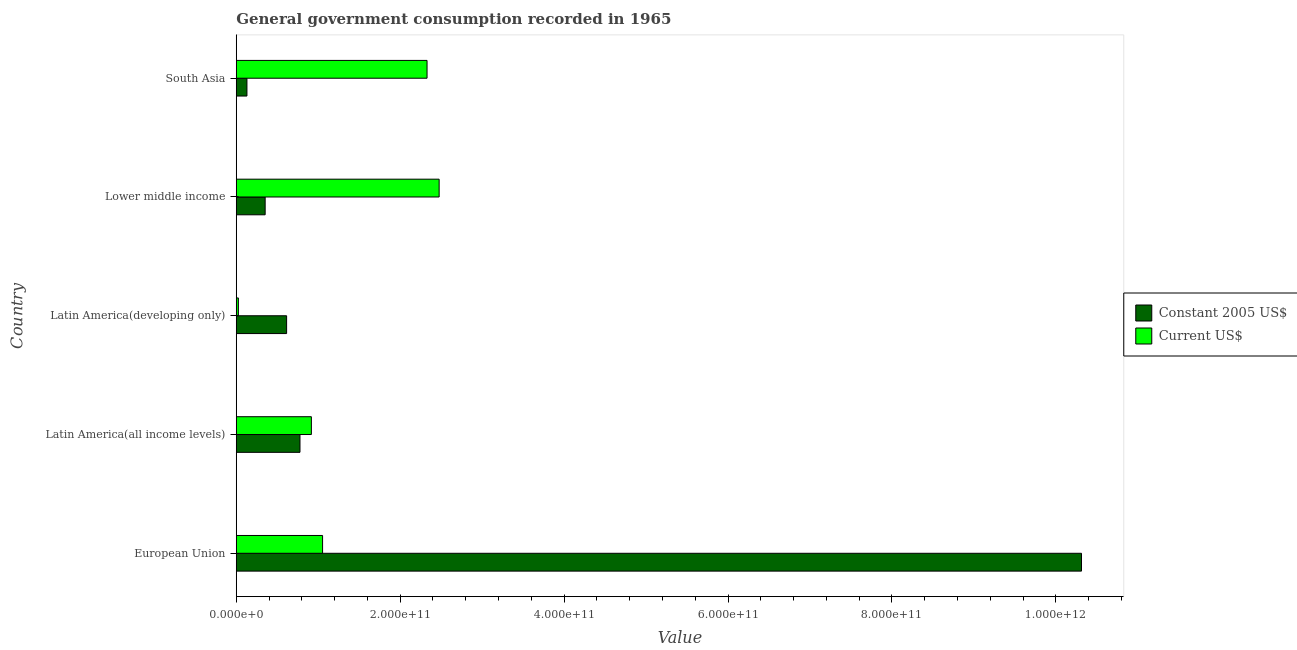How many groups of bars are there?
Ensure brevity in your answer.  5. Are the number of bars per tick equal to the number of legend labels?
Provide a succinct answer. Yes. How many bars are there on the 5th tick from the top?
Make the answer very short. 2. In how many cases, is the number of bars for a given country not equal to the number of legend labels?
Your answer should be very brief. 0. What is the value consumed in constant 2005 us$ in Latin America(all income levels)?
Give a very brief answer. 7.77e+1. Across all countries, what is the maximum value consumed in current us$?
Offer a very short reply. 2.48e+11. Across all countries, what is the minimum value consumed in constant 2005 us$?
Offer a terse response. 1.30e+1. In which country was the value consumed in current us$ maximum?
Ensure brevity in your answer.  Lower middle income. In which country was the value consumed in current us$ minimum?
Provide a short and direct response. Latin America(developing only). What is the total value consumed in constant 2005 us$ in the graph?
Provide a short and direct response. 1.22e+12. What is the difference between the value consumed in current us$ in Latin America(all income levels) and that in South Asia?
Make the answer very short. -1.41e+11. What is the difference between the value consumed in constant 2005 us$ in South Asia and the value consumed in current us$ in European Union?
Your answer should be very brief. -9.23e+1. What is the average value consumed in constant 2005 us$ per country?
Make the answer very short. 2.44e+11. What is the difference between the value consumed in constant 2005 us$ and value consumed in current us$ in South Asia?
Provide a succinct answer. -2.20e+11. What is the ratio of the value consumed in current us$ in European Union to that in Lower middle income?
Offer a terse response. 0.42. Is the difference between the value consumed in constant 2005 us$ in Lower middle income and South Asia greater than the difference between the value consumed in current us$ in Lower middle income and South Asia?
Your response must be concise. Yes. What is the difference between the highest and the second highest value consumed in current us$?
Offer a very short reply. 1.48e+1. What is the difference between the highest and the lowest value consumed in current us$?
Your answer should be compact. 2.45e+11. In how many countries, is the value consumed in current us$ greater than the average value consumed in current us$ taken over all countries?
Keep it short and to the point. 2. What does the 2nd bar from the top in Latin America(all income levels) represents?
Keep it short and to the point. Constant 2005 US$. What does the 1st bar from the bottom in European Union represents?
Offer a terse response. Constant 2005 US$. What is the difference between two consecutive major ticks on the X-axis?
Ensure brevity in your answer.  2.00e+11. Are the values on the major ticks of X-axis written in scientific E-notation?
Ensure brevity in your answer.  Yes. Does the graph contain any zero values?
Provide a short and direct response. No. How many legend labels are there?
Keep it short and to the point. 2. How are the legend labels stacked?
Offer a terse response. Vertical. What is the title of the graph?
Make the answer very short. General government consumption recorded in 1965. What is the label or title of the X-axis?
Keep it short and to the point. Value. What is the Value of Constant 2005 US$ in European Union?
Ensure brevity in your answer.  1.03e+12. What is the Value of Current US$ in European Union?
Ensure brevity in your answer.  1.05e+11. What is the Value in Constant 2005 US$ in Latin America(all income levels)?
Keep it short and to the point. 7.77e+1. What is the Value in Current US$ in Latin America(all income levels)?
Make the answer very short. 9.17e+1. What is the Value in Constant 2005 US$ in Latin America(developing only)?
Offer a terse response. 6.14e+1. What is the Value in Current US$ in Latin America(developing only)?
Give a very brief answer. 2.61e+09. What is the Value of Constant 2005 US$ in Lower middle income?
Provide a short and direct response. 3.53e+1. What is the Value in Current US$ in Lower middle income?
Provide a succinct answer. 2.48e+11. What is the Value in Constant 2005 US$ in South Asia?
Your response must be concise. 1.30e+1. What is the Value of Current US$ in South Asia?
Give a very brief answer. 2.33e+11. Across all countries, what is the maximum Value of Constant 2005 US$?
Offer a very short reply. 1.03e+12. Across all countries, what is the maximum Value in Current US$?
Your answer should be compact. 2.48e+11. Across all countries, what is the minimum Value of Constant 2005 US$?
Your answer should be very brief. 1.30e+1. Across all countries, what is the minimum Value in Current US$?
Your answer should be very brief. 2.61e+09. What is the total Value of Constant 2005 US$ in the graph?
Give a very brief answer. 1.22e+12. What is the total Value in Current US$ in the graph?
Offer a very short reply. 6.80e+11. What is the difference between the Value of Constant 2005 US$ in European Union and that in Latin America(all income levels)?
Ensure brevity in your answer.  9.54e+11. What is the difference between the Value of Current US$ in European Union and that in Latin America(all income levels)?
Make the answer very short. 1.37e+1. What is the difference between the Value of Constant 2005 US$ in European Union and that in Latin America(developing only)?
Provide a succinct answer. 9.70e+11. What is the difference between the Value in Current US$ in European Union and that in Latin America(developing only)?
Provide a succinct answer. 1.03e+11. What is the difference between the Value of Constant 2005 US$ in European Union and that in Lower middle income?
Offer a terse response. 9.96e+11. What is the difference between the Value in Current US$ in European Union and that in Lower middle income?
Provide a short and direct response. -1.42e+11. What is the difference between the Value in Constant 2005 US$ in European Union and that in South Asia?
Keep it short and to the point. 1.02e+12. What is the difference between the Value in Current US$ in European Union and that in South Asia?
Your response must be concise. -1.27e+11. What is the difference between the Value in Constant 2005 US$ in Latin America(all income levels) and that in Latin America(developing only)?
Offer a terse response. 1.63e+1. What is the difference between the Value in Current US$ in Latin America(all income levels) and that in Latin America(developing only)?
Offer a very short reply. 8.91e+1. What is the difference between the Value in Constant 2005 US$ in Latin America(all income levels) and that in Lower middle income?
Give a very brief answer. 4.25e+1. What is the difference between the Value in Current US$ in Latin America(all income levels) and that in Lower middle income?
Your answer should be very brief. -1.56e+11. What is the difference between the Value of Constant 2005 US$ in Latin America(all income levels) and that in South Asia?
Make the answer very short. 6.47e+1. What is the difference between the Value in Current US$ in Latin America(all income levels) and that in South Asia?
Provide a short and direct response. -1.41e+11. What is the difference between the Value of Constant 2005 US$ in Latin America(developing only) and that in Lower middle income?
Provide a short and direct response. 2.62e+1. What is the difference between the Value in Current US$ in Latin America(developing only) and that in Lower middle income?
Keep it short and to the point. -2.45e+11. What is the difference between the Value of Constant 2005 US$ in Latin America(developing only) and that in South Asia?
Offer a terse response. 4.84e+1. What is the difference between the Value of Current US$ in Latin America(developing only) and that in South Asia?
Give a very brief answer. -2.30e+11. What is the difference between the Value of Constant 2005 US$ in Lower middle income and that in South Asia?
Offer a very short reply. 2.22e+1. What is the difference between the Value of Current US$ in Lower middle income and that in South Asia?
Make the answer very short. 1.48e+1. What is the difference between the Value in Constant 2005 US$ in European Union and the Value in Current US$ in Latin America(all income levels)?
Your response must be concise. 9.40e+11. What is the difference between the Value in Constant 2005 US$ in European Union and the Value in Current US$ in Latin America(developing only)?
Provide a short and direct response. 1.03e+12. What is the difference between the Value in Constant 2005 US$ in European Union and the Value in Current US$ in Lower middle income?
Provide a succinct answer. 7.84e+11. What is the difference between the Value in Constant 2005 US$ in European Union and the Value in Current US$ in South Asia?
Provide a succinct answer. 7.98e+11. What is the difference between the Value in Constant 2005 US$ in Latin America(all income levels) and the Value in Current US$ in Latin America(developing only)?
Keep it short and to the point. 7.51e+1. What is the difference between the Value of Constant 2005 US$ in Latin America(all income levels) and the Value of Current US$ in Lower middle income?
Provide a succinct answer. -1.70e+11. What is the difference between the Value of Constant 2005 US$ in Latin America(all income levels) and the Value of Current US$ in South Asia?
Offer a very short reply. -1.55e+11. What is the difference between the Value of Constant 2005 US$ in Latin America(developing only) and the Value of Current US$ in Lower middle income?
Offer a terse response. -1.86e+11. What is the difference between the Value of Constant 2005 US$ in Latin America(developing only) and the Value of Current US$ in South Asia?
Offer a terse response. -1.71e+11. What is the difference between the Value of Constant 2005 US$ in Lower middle income and the Value of Current US$ in South Asia?
Offer a very short reply. -1.98e+11. What is the average Value of Constant 2005 US$ per country?
Keep it short and to the point. 2.44e+11. What is the average Value in Current US$ per country?
Provide a short and direct response. 1.36e+11. What is the difference between the Value of Constant 2005 US$ and Value of Current US$ in European Union?
Provide a short and direct response. 9.26e+11. What is the difference between the Value in Constant 2005 US$ and Value in Current US$ in Latin America(all income levels)?
Make the answer very short. -1.39e+1. What is the difference between the Value in Constant 2005 US$ and Value in Current US$ in Latin America(developing only)?
Your answer should be very brief. 5.88e+1. What is the difference between the Value of Constant 2005 US$ and Value of Current US$ in Lower middle income?
Make the answer very short. -2.12e+11. What is the difference between the Value of Constant 2005 US$ and Value of Current US$ in South Asia?
Offer a very short reply. -2.20e+11. What is the ratio of the Value of Constant 2005 US$ in European Union to that in Latin America(all income levels)?
Your response must be concise. 13.26. What is the ratio of the Value of Current US$ in European Union to that in Latin America(all income levels)?
Offer a very short reply. 1.15. What is the ratio of the Value in Constant 2005 US$ in European Union to that in Latin America(developing only)?
Your answer should be very brief. 16.78. What is the ratio of the Value of Current US$ in European Union to that in Latin America(developing only)?
Offer a very short reply. 40.41. What is the ratio of the Value in Constant 2005 US$ in European Union to that in Lower middle income?
Your answer should be compact. 29.24. What is the ratio of the Value of Current US$ in European Union to that in Lower middle income?
Provide a succinct answer. 0.43. What is the ratio of the Value of Constant 2005 US$ in European Union to that in South Asia?
Offer a very short reply. 79.1. What is the ratio of the Value in Current US$ in European Union to that in South Asia?
Offer a very short reply. 0.45. What is the ratio of the Value of Constant 2005 US$ in Latin America(all income levels) to that in Latin America(developing only)?
Offer a terse response. 1.27. What is the ratio of the Value of Current US$ in Latin America(all income levels) to that in Latin America(developing only)?
Your answer should be very brief. 35.17. What is the ratio of the Value in Constant 2005 US$ in Latin America(all income levels) to that in Lower middle income?
Provide a short and direct response. 2.2. What is the ratio of the Value of Current US$ in Latin America(all income levels) to that in Lower middle income?
Make the answer very short. 0.37. What is the ratio of the Value in Constant 2005 US$ in Latin America(all income levels) to that in South Asia?
Ensure brevity in your answer.  5.96. What is the ratio of the Value in Current US$ in Latin America(all income levels) to that in South Asia?
Your response must be concise. 0.39. What is the ratio of the Value of Constant 2005 US$ in Latin America(developing only) to that in Lower middle income?
Make the answer very short. 1.74. What is the ratio of the Value in Current US$ in Latin America(developing only) to that in Lower middle income?
Make the answer very short. 0.01. What is the ratio of the Value in Constant 2005 US$ in Latin America(developing only) to that in South Asia?
Your answer should be compact. 4.71. What is the ratio of the Value in Current US$ in Latin America(developing only) to that in South Asia?
Your answer should be very brief. 0.01. What is the ratio of the Value in Constant 2005 US$ in Lower middle income to that in South Asia?
Offer a very short reply. 2.71. What is the ratio of the Value of Current US$ in Lower middle income to that in South Asia?
Provide a short and direct response. 1.06. What is the difference between the highest and the second highest Value in Constant 2005 US$?
Your answer should be compact. 9.54e+11. What is the difference between the highest and the second highest Value of Current US$?
Offer a very short reply. 1.48e+1. What is the difference between the highest and the lowest Value in Constant 2005 US$?
Provide a succinct answer. 1.02e+12. What is the difference between the highest and the lowest Value in Current US$?
Provide a succinct answer. 2.45e+11. 